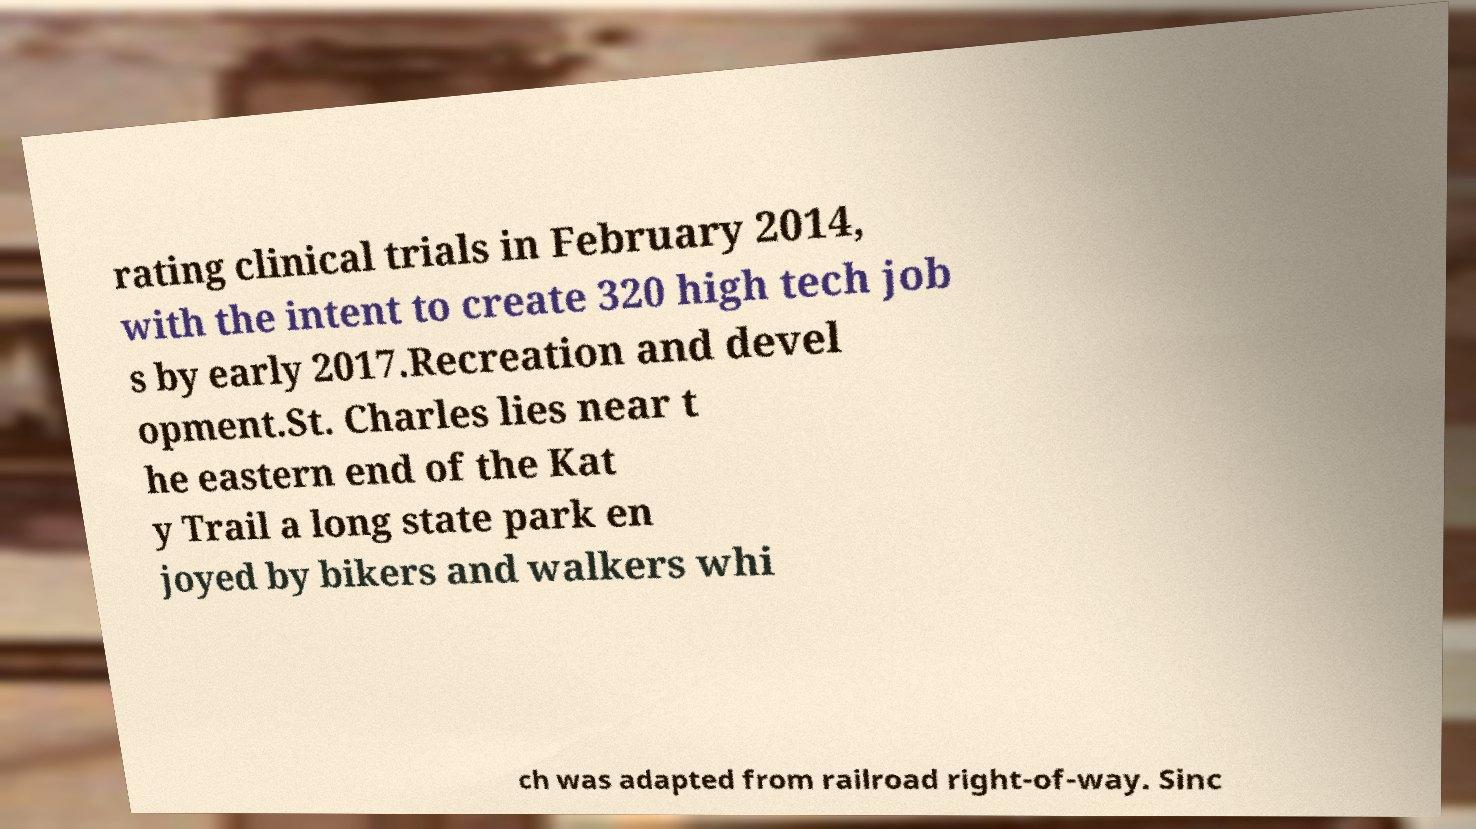There's text embedded in this image that I need extracted. Can you transcribe it verbatim? rating clinical trials in February 2014, with the intent to create 320 high tech job s by early 2017.Recreation and devel opment.St. Charles lies near t he eastern end of the Kat y Trail a long state park en joyed by bikers and walkers whi ch was adapted from railroad right-of-way. Sinc 